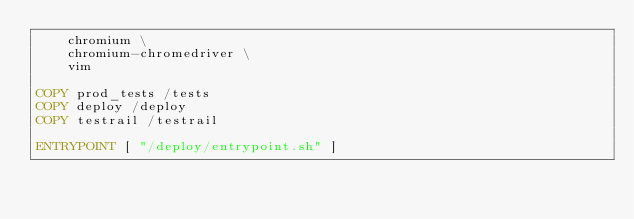<code> <loc_0><loc_0><loc_500><loc_500><_Dockerfile_>    chromium \
    chromium-chromedriver \
    vim

COPY prod_tests /tests
COPY deploy /deploy
COPY testrail /testrail

ENTRYPOINT [ "/deploy/entrypoint.sh" ]
</code> 